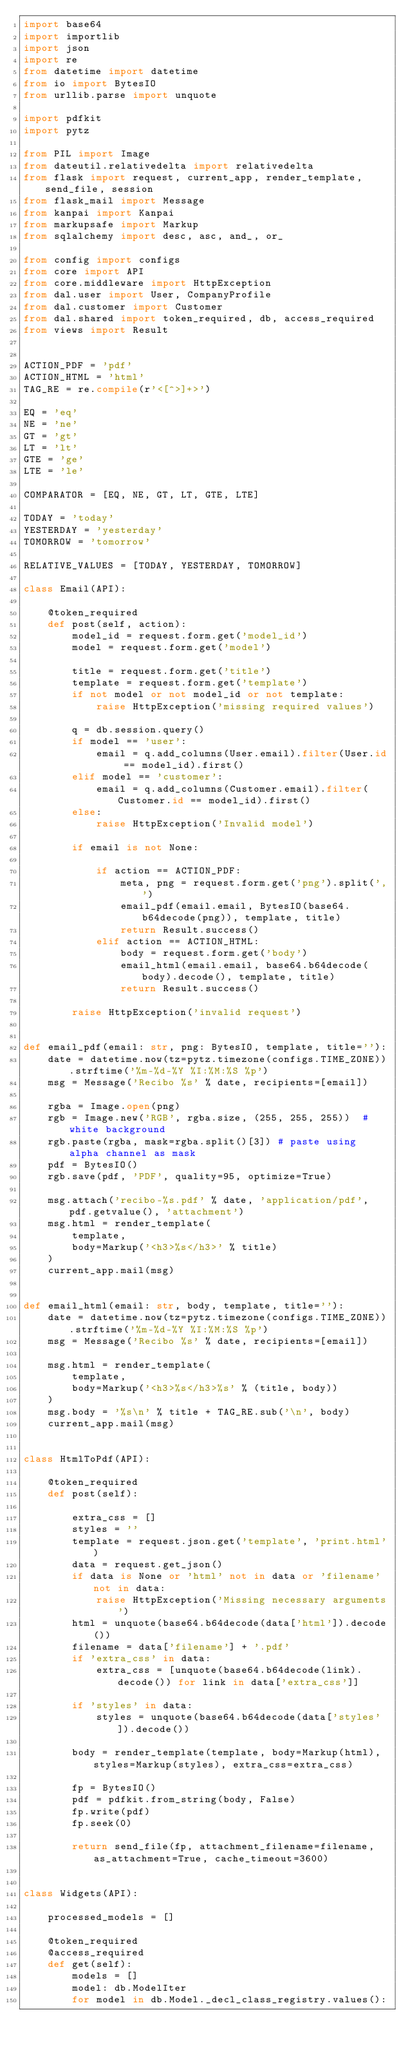<code> <loc_0><loc_0><loc_500><loc_500><_Python_>import base64
import importlib
import json
import re
from datetime import datetime
from io import BytesIO
from urllib.parse import unquote

import pdfkit
import pytz

from PIL import Image
from dateutil.relativedelta import relativedelta
from flask import request, current_app, render_template, send_file, session
from flask_mail import Message
from kanpai import Kanpai
from markupsafe import Markup
from sqlalchemy import desc, asc, and_, or_

from config import configs
from core import API
from core.middleware import HttpException
from dal.user import User, CompanyProfile
from dal.customer import Customer
from dal.shared import token_required, db, access_required
from views import Result


ACTION_PDF = 'pdf'
ACTION_HTML = 'html'
TAG_RE = re.compile(r'<[^>]+>')

EQ = 'eq'
NE = 'ne'
GT = 'gt'
LT = 'lt'
GTE = 'ge'
LTE = 'le'

COMPARATOR = [EQ, NE, GT, LT, GTE, LTE]

TODAY = 'today'
YESTERDAY = 'yesterday'
TOMORROW = 'tomorrow'

RELATIVE_VALUES = [TODAY, YESTERDAY, TOMORROW]

class Email(API):

    @token_required
    def post(self, action):
        model_id = request.form.get('model_id')
        model = request.form.get('model')

        title = request.form.get('title')
        template = request.form.get('template')
        if not model or not model_id or not template:
            raise HttpException('missing required values')

        q = db.session.query()
        if model == 'user':
            email = q.add_columns(User.email).filter(User.id == model_id).first()
        elif model == 'customer':
            email = q.add_columns(Customer.email).filter(Customer.id == model_id).first()
        else:
            raise HttpException('Invalid model')

        if email is not None:

            if action == ACTION_PDF:
                meta, png = request.form.get('png').split(',')
                email_pdf(email.email, BytesIO(base64.b64decode(png)), template, title)
                return Result.success()
            elif action == ACTION_HTML:
                body = request.form.get('body')
                email_html(email.email, base64.b64decode(body).decode(), template, title)
                return Result.success()

        raise HttpException('invalid request')


def email_pdf(email: str, png: BytesIO, template, title=''):
    date = datetime.now(tz=pytz.timezone(configs.TIME_ZONE)).strftime('%m-%d-%Y %I:%M:%S %p')
    msg = Message('Recibo %s' % date, recipients=[email])

    rgba = Image.open(png)
    rgb = Image.new('RGB', rgba.size, (255, 255, 255))  # white background
    rgb.paste(rgba, mask=rgba.split()[3]) # paste using alpha channel as mask
    pdf = BytesIO()
    rgb.save(pdf, 'PDF', quality=95, optimize=True)

    msg.attach('recibo-%s.pdf' % date, 'application/pdf', pdf.getvalue(), 'attachment')
    msg.html = render_template(
        template,
        body=Markup('<h3>%s</h3>' % title)
    )
    current_app.mail(msg)


def email_html(email: str, body, template, title=''):
    date = datetime.now(tz=pytz.timezone(configs.TIME_ZONE)).strftime('%m-%d-%Y %I:%M:%S %p')
    msg = Message('Recibo %s' % date, recipients=[email])

    msg.html = render_template(
        template,
        body=Markup('<h3>%s</h3>%s' % (title, body))
    )
    msg.body = '%s\n' % title + TAG_RE.sub('\n', body)
    current_app.mail(msg)


class HtmlToPdf(API):

    @token_required
    def post(self):

        extra_css = []
        styles = ''
        template = request.json.get('template', 'print.html')
        data = request.get_json()
        if data is None or 'html' not in data or 'filename' not in data:
            raise HttpException('Missing necessary arguments')
        html = unquote(base64.b64decode(data['html']).decode())
        filename = data['filename'] + '.pdf'
        if 'extra_css' in data:
            extra_css = [unquote(base64.b64decode(link).decode()) for link in data['extra_css']]

        if 'styles' in data:
            styles = unquote(base64.b64decode(data['styles']).decode())

        body = render_template(template, body=Markup(html), styles=Markup(styles), extra_css=extra_css)

        fp = BytesIO()
        pdf = pdfkit.from_string(body, False)
        fp.write(pdf)
        fp.seek(0)

        return send_file(fp, attachment_filename=filename, as_attachment=True, cache_timeout=3600)


class Widgets(API):

    processed_models = []

    @token_required
    @access_required
    def get(self):
        models = []
        model: db.ModelIter
        for model in db.Model._decl_class_registry.values():</code> 